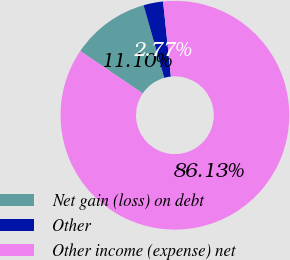Convert chart. <chart><loc_0><loc_0><loc_500><loc_500><pie_chart><fcel>Net gain (loss) on debt<fcel>Other<fcel>Other income (expense) net<nl><fcel>11.1%<fcel>2.77%<fcel>86.13%<nl></chart> 